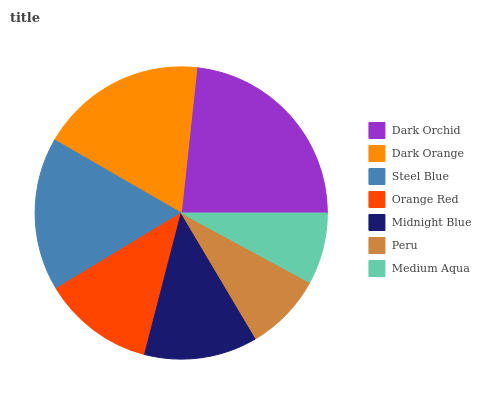Is Medium Aqua the minimum?
Answer yes or no. Yes. Is Dark Orchid the maximum?
Answer yes or no. Yes. Is Dark Orange the minimum?
Answer yes or no. No. Is Dark Orange the maximum?
Answer yes or no. No. Is Dark Orchid greater than Dark Orange?
Answer yes or no. Yes. Is Dark Orange less than Dark Orchid?
Answer yes or no. Yes. Is Dark Orange greater than Dark Orchid?
Answer yes or no. No. Is Dark Orchid less than Dark Orange?
Answer yes or no. No. Is Midnight Blue the high median?
Answer yes or no. Yes. Is Midnight Blue the low median?
Answer yes or no. Yes. Is Steel Blue the high median?
Answer yes or no. No. Is Dark Orange the low median?
Answer yes or no. No. 